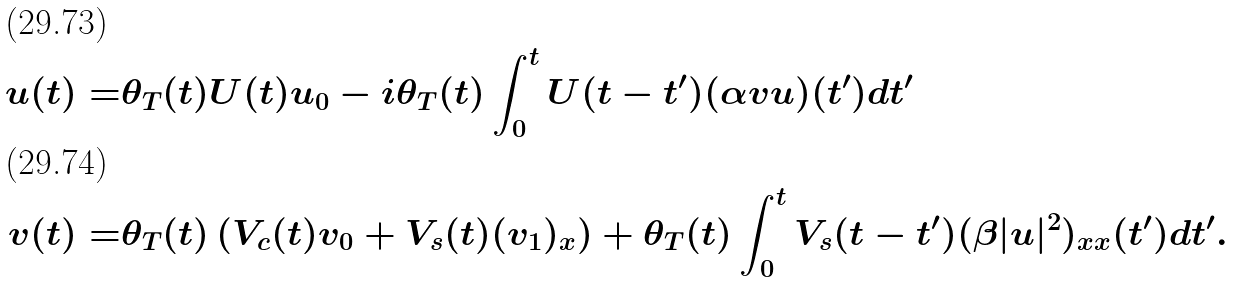Convert formula to latex. <formula><loc_0><loc_0><loc_500><loc_500>u ( t ) = & \theta _ { T } ( t ) U ( t ) u _ { 0 } - i \theta _ { T } ( t ) \int _ { 0 } ^ { t } U ( t - t ^ { \prime } ) ( \alpha v u ) ( t ^ { \prime } ) d t ^ { \prime } \\ v ( t ) = & \theta _ { T } ( t ) \left ( V _ { c } ( t ) v _ { 0 } + V _ { s } ( t ) ( v _ { 1 } ) _ { x } \right ) + \theta _ { T } ( t ) \int _ { 0 } ^ { t } V _ { s } ( t - t ^ { \prime } ) ( \beta | u | ^ { 2 } ) _ { x x } ( t ^ { \prime } ) d t ^ { \prime } .</formula> 